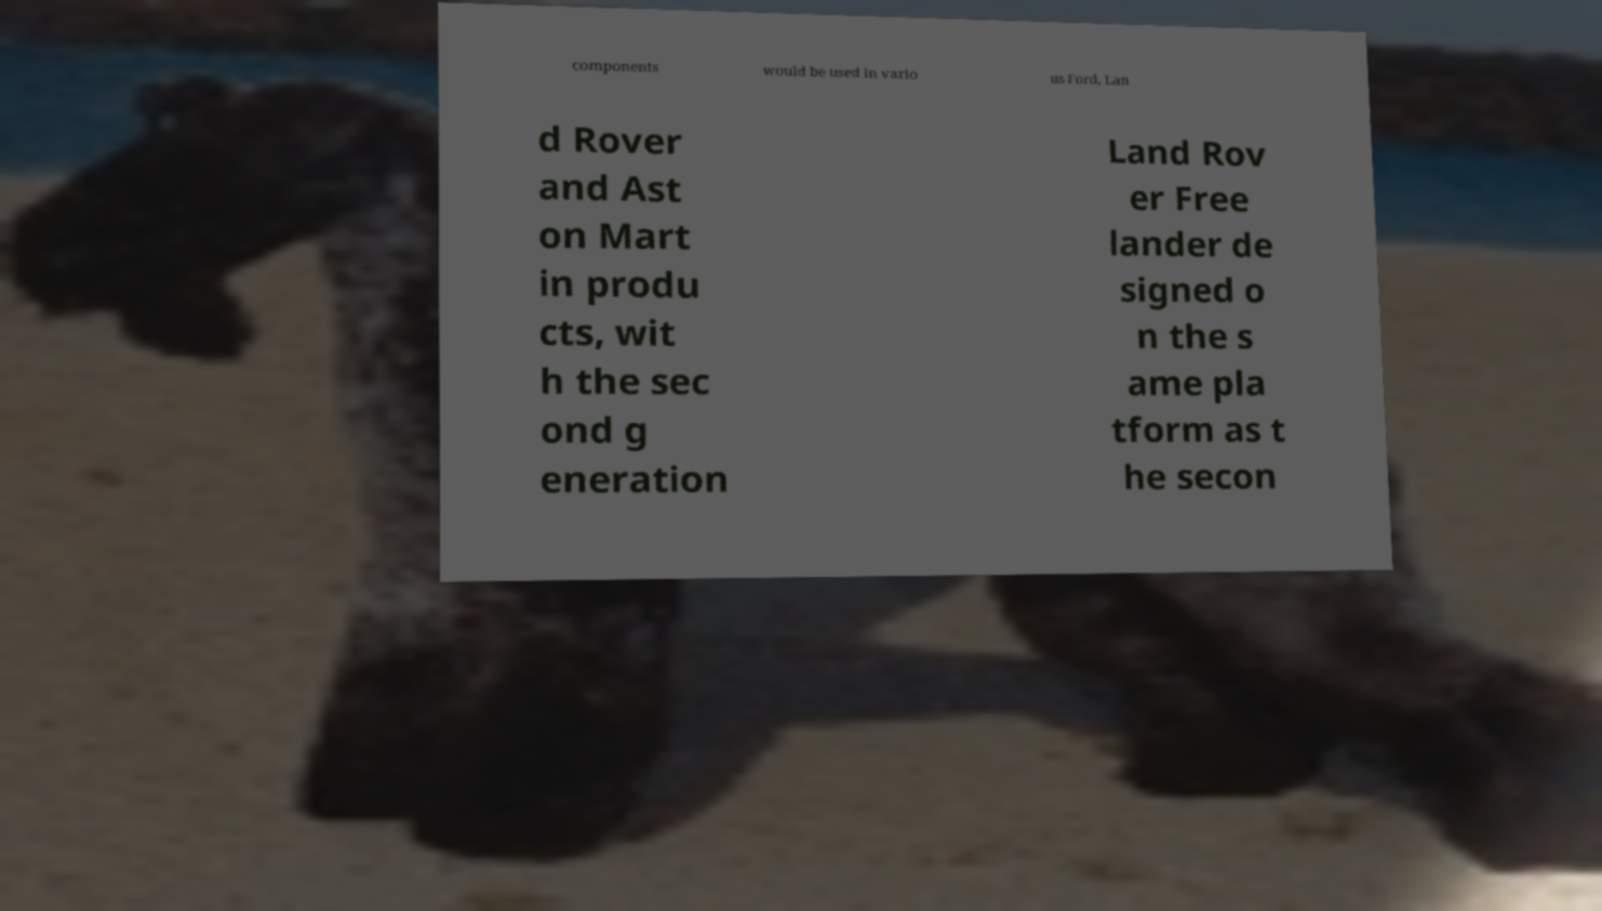Can you read and provide the text displayed in the image?This photo seems to have some interesting text. Can you extract and type it out for me? components would be used in vario us Ford, Lan d Rover and Ast on Mart in produ cts, wit h the sec ond g eneration Land Rov er Free lander de signed o n the s ame pla tform as t he secon 